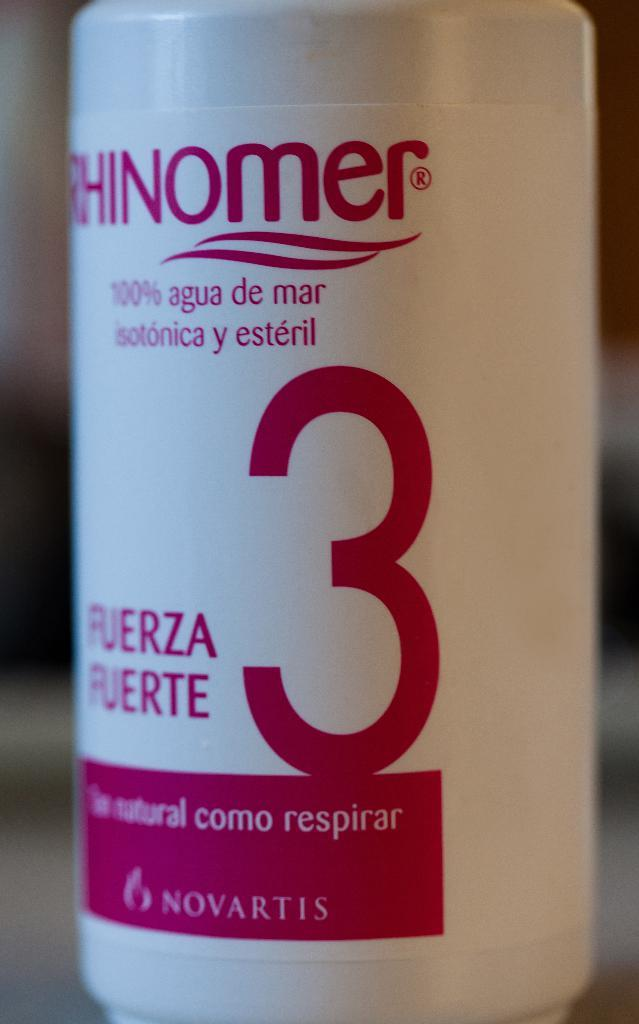<image>
Describe the image concisely. a bottle with the number 3 on it next to FUERZA FUERTE 